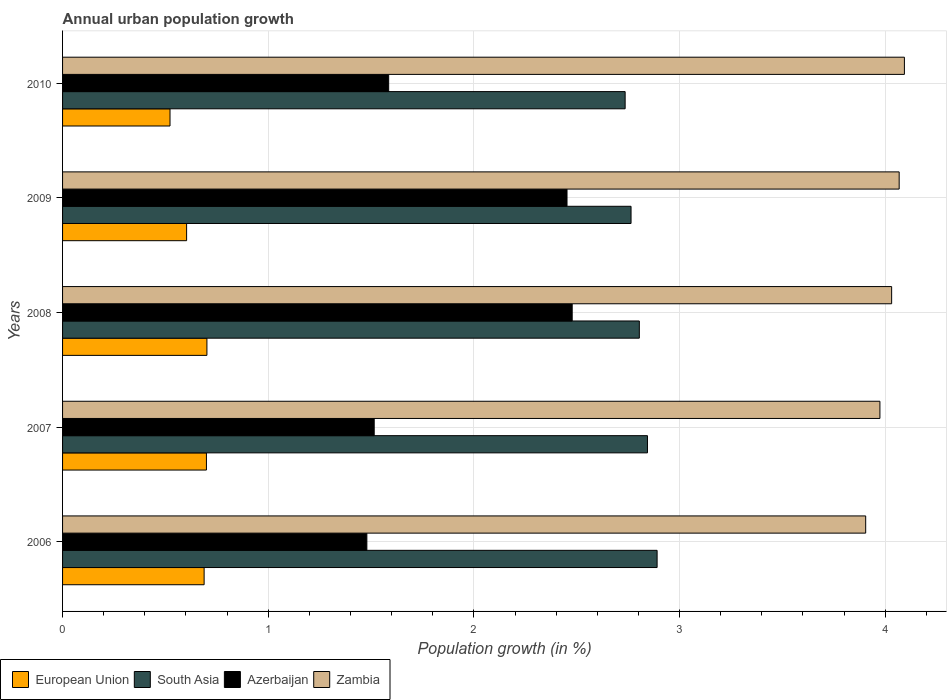How many groups of bars are there?
Provide a succinct answer. 5. Are the number of bars on each tick of the Y-axis equal?
Keep it short and to the point. Yes. In how many cases, is the number of bars for a given year not equal to the number of legend labels?
Offer a terse response. 0. What is the percentage of urban population growth in Zambia in 2006?
Offer a very short reply. 3.91. Across all years, what is the maximum percentage of urban population growth in South Asia?
Your answer should be very brief. 2.89. Across all years, what is the minimum percentage of urban population growth in Zambia?
Offer a terse response. 3.91. In which year was the percentage of urban population growth in Zambia maximum?
Make the answer very short. 2010. What is the total percentage of urban population growth in Zambia in the graph?
Your response must be concise. 20.07. What is the difference between the percentage of urban population growth in South Asia in 2007 and that in 2009?
Your answer should be compact. 0.08. What is the difference between the percentage of urban population growth in Azerbaijan in 2006 and the percentage of urban population growth in European Union in 2007?
Keep it short and to the point. 0.78. What is the average percentage of urban population growth in Zambia per year?
Your answer should be very brief. 4.01. In the year 2010, what is the difference between the percentage of urban population growth in Zambia and percentage of urban population growth in Azerbaijan?
Your response must be concise. 2.51. In how many years, is the percentage of urban population growth in South Asia greater than 0.8 %?
Your answer should be compact. 5. What is the ratio of the percentage of urban population growth in Zambia in 2008 to that in 2009?
Make the answer very short. 0.99. Is the percentage of urban population growth in Zambia in 2007 less than that in 2009?
Give a very brief answer. Yes. What is the difference between the highest and the second highest percentage of urban population growth in Azerbaijan?
Your answer should be compact. 0.03. What is the difference between the highest and the lowest percentage of urban population growth in Zambia?
Provide a succinct answer. 0.19. In how many years, is the percentage of urban population growth in Azerbaijan greater than the average percentage of urban population growth in Azerbaijan taken over all years?
Give a very brief answer. 2. Is it the case that in every year, the sum of the percentage of urban population growth in European Union and percentage of urban population growth in Zambia is greater than the sum of percentage of urban population growth in South Asia and percentage of urban population growth in Azerbaijan?
Keep it short and to the point. Yes. What does the 3rd bar from the bottom in 2009 represents?
Offer a terse response. Azerbaijan. Are all the bars in the graph horizontal?
Give a very brief answer. Yes. Are the values on the major ticks of X-axis written in scientific E-notation?
Give a very brief answer. No. Does the graph contain grids?
Provide a succinct answer. Yes. Where does the legend appear in the graph?
Ensure brevity in your answer.  Bottom left. How many legend labels are there?
Give a very brief answer. 4. What is the title of the graph?
Keep it short and to the point. Annual urban population growth. Does "Sint Maarten (Dutch part)" appear as one of the legend labels in the graph?
Give a very brief answer. No. What is the label or title of the X-axis?
Give a very brief answer. Population growth (in %). What is the label or title of the Y-axis?
Give a very brief answer. Years. What is the Population growth (in %) of European Union in 2006?
Your answer should be compact. 0.69. What is the Population growth (in %) in South Asia in 2006?
Keep it short and to the point. 2.89. What is the Population growth (in %) of Azerbaijan in 2006?
Provide a short and direct response. 1.48. What is the Population growth (in %) of Zambia in 2006?
Provide a short and direct response. 3.91. What is the Population growth (in %) of European Union in 2007?
Keep it short and to the point. 0.7. What is the Population growth (in %) in South Asia in 2007?
Offer a very short reply. 2.84. What is the Population growth (in %) in Azerbaijan in 2007?
Make the answer very short. 1.52. What is the Population growth (in %) of Zambia in 2007?
Your answer should be very brief. 3.97. What is the Population growth (in %) in European Union in 2008?
Offer a very short reply. 0.7. What is the Population growth (in %) of South Asia in 2008?
Keep it short and to the point. 2.8. What is the Population growth (in %) in Azerbaijan in 2008?
Ensure brevity in your answer.  2.48. What is the Population growth (in %) of Zambia in 2008?
Ensure brevity in your answer.  4.03. What is the Population growth (in %) of European Union in 2009?
Your answer should be compact. 0.6. What is the Population growth (in %) of South Asia in 2009?
Provide a succinct answer. 2.76. What is the Population growth (in %) of Azerbaijan in 2009?
Provide a succinct answer. 2.45. What is the Population growth (in %) of Zambia in 2009?
Offer a very short reply. 4.07. What is the Population growth (in %) of European Union in 2010?
Make the answer very short. 0.52. What is the Population growth (in %) in South Asia in 2010?
Make the answer very short. 2.74. What is the Population growth (in %) in Azerbaijan in 2010?
Your answer should be compact. 1.59. What is the Population growth (in %) in Zambia in 2010?
Make the answer very short. 4.09. Across all years, what is the maximum Population growth (in %) of European Union?
Your response must be concise. 0.7. Across all years, what is the maximum Population growth (in %) of South Asia?
Offer a terse response. 2.89. Across all years, what is the maximum Population growth (in %) in Azerbaijan?
Provide a short and direct response. 2.48. Across all years, what is the maximum Population growth (in %) of Zambia?
Keep it short and to the point. 4.09. Across all years, what is the minimum Population growth (in %) in European Union?
Your answer should be compact. 0.52. Across all years, what is the minimum Population growth (in %) in South Asia?
Ensure brevity in your answer.  2.74. Across all years, what is the minimum Population growth (in %) of Azerbaijan?
Your answer should be compact. 1.48. Across all years, what is the minimum Population growth (in %) in Zambia?
Give a very brief answer. 3.91. What is the total Population growth (in %) of European Union in the graph?
Your answer should be compact. 3.22. What is the total Population growth (in %) of South Asia in the graph?
Provide a short and direct response. 14.04. What is the total Population growth (in %) of Azerbaijan in the graph?
Provide a short and direct response. 9.51. What is the total Population growth (in %) in Zambia in the graph?
Your response must be concise. 20.07. What is the difference between the Population growth (in %) of European Union in 2006 and that in 2007?
Keep it short and to the point. -0.01. What is the difference between the Population growth (in %) in South Asia in 2006 and that in 2007?
Make the answer very short. 0.05. What is the difference between the Population growth (in %) in Azerbaijan in 2006 and that in 2007?
Keep it short and to the point. -0.04. What is the difference between the Population growth (in %) of Zambia in 2006 and that in 2007?
Make the answer very short. -0.07. What is the difference between the Population growth (in %) of European Union in 2006 and that in 2008?
Your response must be concise. -0.01. What is the difference between the Population growth (in %) of South Asia in 2006 and that in 2008?
Provide a succinct answer. 0.09. What is the difference between the Population growth (in %) in Azerbaijan in 2006 and that in 2008?
Ensure brevity in your answer.  -1. What is the difference between the Population growth (in %) in Zambia in 2006 and that in 2008?
Give a very brief answer. -0.13. What is the difference between the Population growth (in %) in European Union in 2006 and that in 2009?
Offer a terse response. 0.09. What is the difference between the Population growth (in %) in South Asia in 2006 and that in 2009?
Give a very brief answer. 0.13. What is the difference between the Population growth (in %) of Azerbaijan in 2006 and that in 2009?
Provide a succinct answer. -0.97. What is the difference between the Population growth (in %) of Zambia in 2006 and that in 2009?
Provide a short and direct response. -0.16. What is the difference between the Population growth (in %) of European Union in 2006 and that in 2010?
Offer a terse response. 0.17. What is the difference between the Population growth (in %) in South Asia in 2006 and that in 2010?
Give a very brief answer. 0.16. What is the difference between the Population growth (in %) of Azerbaijan in 2006 and that in 2010?
Your response must be concise. -0.11. What is the difference between the Population growth (in %) of Zambia in 2006 and that in 2010?
Keep it short and to the point. -0.19. What is the difference between the Population growth (in %) in European Union in 2007 and that in 2008?
Offer a terse response. -0. What is the difference between the Population growth (in %) in South Asia in 2007 and that in 2008?
Make the answer very short. 0.04. What is the difference between the Population growth (in %) in Azerbaijan in 2007 and that in 2008?
Make the answer very short. -0.96. What is the difference between the Population growth (in %) in Zambia in 2007 and that in 2008?
Ensure brevity in your answer.  -0.06. What is the difference between the Population growth (in %) of European Union in 2007 and that in 2009?
Provide a succinct answer. 0.1. What is the difference between the Population growth (in %) in South Asia in 2007 and that in 2009?
Your response must be concise. 0.08. What is the difference between the Population growth (in %) in Azerbaijan in 2007 and that in 2009?
Your response must be concise. -0.94. What is the difference between the Population growth (in %) in Zambia in 2007 and that in 2009?
Offer a terse response. -0.09. What is the difference between the Population growth (in %) of European Union in 2007 and that in 2010?
Keep it short and to the point. 0.18. What is the difference between the Population growth (in %) in South Asia in 2007 and that in 2010?
Keep it short and to the point. 0.11. What is the difference between the Population growth (in %) in Azerbaijan in 2007 and that in 2010?
Your answer should be very brief. -0.07. What is the difference between the Population growth (in %) of Zambia in 2007 and that in 2010?
Make the answer very short. -0.12. What is the difference between the Population growth (in %) in European Union in 2008 and that in 2009?
Provide a succinct answer. 0.1. What is the difference between the Population growth (in %) in South Asia in 2008 and that in 2009?
Make the answer very short. 0.04. What is the difference between the Population growth (in %) in Azerbaijan in 2008 and that in 2009?
Ensure brevity in your answer.  0.03. What is the difference between the Population growth (in %) in Zambia in 2008 and that in 2009?
Offer a very short reply. -0.04. What is the difference between the Population growth (in %) of European Union in 2008 and that in 2010?
Your response must be concise. 0.18. What is the difference between the Population growth (in %) in South Asia in 2008 and that in 2010?
Your answer should be compact. 0.07. What is the difference between the Population growth (in %) of Azerbaijan in 2008 and that in 2010?
Provide a succinct answer. 0.89. What is the difference between the Population growth (in %) in Zambia in 2008 and that in 2010?
Keep it short and to the point. -0.06. What is the difference between the Population growth (in %) of European Union in 2009 and that in 2010?
Give a very brief answer. 0.08. What is the difference between the Population growth (in %) of South Asia in 2009 and that in 2010?
Give a very brief answer. 0.03. What is the difference between the Population growth (in %) of Azerbaijan in 2009 and that in 2010?
Offer a terse response. 0.87. What is the difference between the Population growth (in %) of Zambia in 2009 and that in 2010?
Make the answer very short. -0.03. What is the difference between the Population growth (in %) of European Union in 2006 and the Population growth (in %) of South Asia in 2007?
Keep it short and to the point. -2.16. What is the difference between the Population growth (in %) of European Union in 2006 and the Population growth (in %) of Azerbaijan in 2007?
Keep it short and to the point. -0.83. What is the difference between the Population growth (in %) in European Union in 2006 and the Population growth (in %) in Zambia in 2007?
Give a very brief answer. -3.29. What is the difference between the Population growth (in %) of South Asia in 2006 and the Population growth (in %) of Azerbaijan in 2007?
Provide a short and direct response. 1.38. What is the difference between the Population growth (in %) in South Asia in 2006 and the Population growth (in %) in Zambia in 2007?
Provide a short and direct response. -1.08. What is the difference between the Population growth (in %) of Azerbaijan in 2006 and the Population growth (in %) of Zambia in 2007?
Your answer should be very brief. -2.49. What is the difference between the Population growth (in %) in European Union in 2006 and the Population growth (in %) in South Asia in 2008?
Offer a very short reply. -2.12. What is the difference between the Population growth (in %) in European Union in 2006 and the Population growth (in %) in Azerbaijan in 2008?
Offer a terse response. -1.79. What is the difference between the Population growth (in %) in European Union in 2006 and the Population growth (in %) in Zambia in 2008?
Make the answer very short. -3.34. What is the difference between the Population growth (in %) in South Asia in 2006 and the Population growth (in %) in Azerbaijan in 2008?
Provide a short and direct response. 0.41. What is the difference between the Population growth (in %) in South Asia in 2006 and the Population growth (in %) in Zambia in 2008?
Your response must be concise. -1.14. What is the difference between the Population growth (in %) of Azerbaijan in 2006 and the Population growth (in %) of Zambia in 2008?
Give a very brief answer. -2.55. What is the difference between the Population growth (in %) in European Union in 2006 and the Population growth (in %) in South Asia in 2009?
Your answer should be very brief. -2.08. What is the difference between the Population growth (in %) of European Union in 2006 and the Population growth (in %) of Azerbaijan in 2009?
Offer a terse response. -1.76. What is the difference between the Population growth (in %) of European Union in 2006 and the Population growth (in %) of Zambia in 2009?
Offer a very short reply. -3.38. What is the difference between the Population growth (in %) of South Asia in 2006 and the Population growth (in %) of Azerbaijan in 2009?
Keep it short and to the point. 0.44. What is the difference between the Population growth (in %) in South Asia in 2006 and the Population growth (in %) in Zambia in 2009?
Provide a short and direct response. -1.18. What is the difference between the Population growth (in %) in Azerbaijan in 2006 and the Population growth (in %) in Zambia in 2009?
Offer a terse response. -2.59. What is the difference between the Population growth (in %) in European Union in 2006 and the Population growth (in %) in South Asia in 2010?
Keep it short and to the point. -2.05. What is the difference between the Population growth (in %) of European Union in 2006 and the Population growth (in %) of Azerbaijan in 2010?
Offer a terse response. -0.9. What is the difference between the Population growth (in %) in European Union in 2006 and the Population growth (in %) in Zambia in 2010?
Offer a very short reply. -3.4. What is the difference between the Population growth (in %) of South Asia in 2006 and the Population growth (in %) of Azerbaijan in 2010?
Your answer should be compact. 1.31. What is the difference between the Population growth (in %) of South Asia in 2006 and the Population growth (in %) of Zambia in 2010?
Give a very brief answer. -1.2. What is the difference between the Population growth (in %) in Azerbaijan in 2006 and the Population growth (in %) in Zambia in 2010?
Ensure brevity in your answer.  -2.61. What is the difference between the Population growth (in %) of European Union in 2007 and the Population growth (in %) of South Asia in 2008?
Give a very brief answer. -2.1. What is the difference between the Population growth (in %) of European Union in 2007 and the Population growth (in %) of Azerbaijan in 2008?
Make the answer very short. -1.78. What is the difference between the Population growth (in %) in European Union in 2007 and the Population growth (in %) in Zambia in 2008?
Ensure brevity in your answer.  -3.33. What is the difference between the Population growth (in %) of South Asia in 2007 and the Population growth (in %) of Azerbaijan in 2008?
Offer a terse response. 0.37. What is the difference between the Population growth (in %) of South Asia in 2007 and the Population growth (in %) of Zambia in 2008?
Your answer should be very brief. -1.19. What is the difference between the Population growth (in %) in Azerbaijan in 2007 and the Population growth (in %) in Zambia in 2008?
Offer a terse response. -2.52. What is the difference between the Population growth (in %) of European Union in 2007 and the Population growth (in %) of South Asia in 2009?
Offer a terse response. -2.06. What is the difference between the Population growth (in %) in European Union in 2007 and the Population growth (in %) in Azerbaijan in 2009?
Your answer should be very brief. -1.75. What is the difference between the Population growth (in %) in European Union in 2007 and the Population growth (in %) in Zambia in 2009?
Ensure brevity in your answer.  -3.37. What is the difference between the Population growth (in %) in South Asia in 2007 and the Population growth (in %) in Azerbaijan in 2009?
Provide a succinct answer. 0.39. What is the difference between the Population growth (in %) of South Asia in 2007 and the Population growth (in %) of Zambia in 2009?
Your response must be concise. -1.22. What is the difference between the Population growth (in %) in Azerbaijan in 2007 and the Population growth (in %) in Zambia in 2009?
Provide a succinct answer. -2.55. What is the difference between the Population growth (in %) in European Union in 2007 and the Population growth (in %) in South Asia in 2010?
Make the answer very short. -2.04. What is the difference between the Population growth (in %) in European Union in 2007 and the Population growth (in %) in Azerbaijan in 2010?
Offer a very short reply. -0.89. What is the difference between the Population growth (in %) of European Union in 2007 and the Population growth (in %) of Zambia in 2010?
Provide a succinct answer. -3.39. What is the difference between the Population growth (in %) of South Asia in 2007 and the Population growth (in %) of Azerbaijan in 2010?
Keep it short and to the point. 1.26. What is the difference between the Population growth (in %) in South Asia in 2007 and the Population growth (in %) in Zambia in 2010?
Offer a terse response. -1.25. What is the difference between the Population growth (in %) of Azerbaijan in 2007 and the Population growth (in %) of Zambia in 2010?
Your answer should be very brief. -2.58. What is the difference between the Population growth (in %) of European Union in 2008 and the Population growth (in %) of South Asia in 2009?
Your answer should be compact. -2.06. What is the difference between the Population growth (in %) of European Union in 2008 and the Population growth (in %) of Azerbaijan in 2009?
Provide a succinct answer. -1.75. What is the difference between the Population growth (in %) of European Union in 2008 and the Population growth (in %) of Zambia in 2009?
Keep it short and to the point. -3.37. What is the difference between the Population growth (in %) in South Asia in 2008 and the Population growth (in %) in Azerbaijan in 2009?
Offer a very short reply. 0.35. What is the difference between the Population growth (in %) in South Asia in 2008 and the Population growth (in %) in Zambia in 2009?
Give a very brief answer. -1.26. What is the difference between the Population growth (in %) in Azerbaijan in 2008 and the Population growth (in %) in Zambia in 2009?
Provide a succinct answer. -1.59. What is the difference between the Population growth (in %) in European Union in 2008 and the Population growth (in %) in South Asia in 2010?
Ensure brevity in your answer.  -2.03. What is the difference between the Population growth (in %) in European Union in 2008 and the Population growth (in %) in Azerbaijan in 2010?
Make the answer very short. -0.88. What is the difference between the Population growth (in %) of European Union in 2008 and the Population growth (in %) of Zambia in 2010?
Offer a terse response. -3.39. What is the difference between the Population growth (in %) in South Asia in 2008 and the Population growth (in %) in Azerbaijan in 2010?
Provide a succinct answer. 1.22. What is the difference between the Population growth (in %) in South Asia in 2008 and the Population growth (in %) in Zambia in 2010?
Your answer should be compact. -1.29. What is the difference between the Population growth (in %) of Azerbaijan in 2008 and the Population growth (in %) of Zambia in 2010?
Offer a terse response. -1.62. What is the difference between the Population growth (in %) of European Union in 2009 and the Population growth (in %) of South Asia in 2010?
Keep it short and to the point. -2.13. What is the difference between the Population growth (in %) of European Union in 2009 and the Population growth (in %) of Azerbaijan in 2010?
Your answer should be very brief. -0.98. What is the difference between the Population growth (in %) in European Union in 2009 and the Population growth (in %) in Zambia in 2010?
Provide a short and direct response. -3.49. What is the difference between the Population growth (in %) in South Asia in 2009 and the Population growth (in %) in Azerbaijan in 2010?
Offer a very short reply. 1.18. What is the difference between the Population growth (in %) of South Asia in 2009 and the Population growth (in %) of Zambia in 2010?
Offer a terse response. -1.33. What is the difference between the Population growth (in %) in Azerbaijan in 2009 and the Population growth (in %) in Zambia in 2010?
Provide a short and direct response. -1.64. What is the average Population growth (in %) in European Union per year?
Keep it short and to the point. 0.64. What is the average Population growth (in %) of South Asia per year?
Keep it short and to the point. 2.81. What is the average Population growth (in %) in Azerbaijan per year?
Keep it short and to the point. 1.9. What is the average Population growth (in %) of Zambia per year?
Give a very brief answer. 4.01. In the year 2006, what is the difference between the Population growth (in %) of European Union and Population growth (in %) of South Asia?
Offer a very short reply. -2.2. In the year 2006, what is the difference between the Population growth (in %) in European Union and Population growth (in %) in Azerbaijan?
Your answer should be compact. -0.79. In the year 2006, what is the difference between the Population growth (in %) in European Union and Population growth (in %) in Zambia?
Your response must be concise. -3.22. In the year 2006, what is the difference between the Population growth (in %) of South Asia and Population growth (in %) of Azerbaijan?
Offer a terse response. 1.41. In the year 2006, what is the difference between the Population growth (in %) of South Asia and Population growth (in %) of Zambia?
Provide a succinct answer. -1.01. In the year 2006, what is the difference between the Population growth (in %) of Azerbaijan and Population growth (in %) of Zambia?
Ensure brevity in your answer.  -2.43. In the year 2007, what is the difference between the Population growth (in %) in European Union and Population growth (in %) in South Asia?
Ensure brevity in your answer.  -2.14. In the year 2007, what is the difference between the Population growth (in %) of European Union and Population growth (in %) of Azerbaijan?
Provide a succinct answer. -0.82. In the year 2007, what is the difference between the Population growth (in %) of European Union and Population growth (in %) of Zambia?
Your answer should be very brief. -3.27. In the year 2007, what is the difference between the Population growth (in %) of South Asia and Population growth (in %) of Azerbaijan?
Your answer should be very brief. 1.33. In the year 2007, what is the difference between the Population growth (in %) of South Asia and Population growth (in %) of Zambia?
Offer a very short reply. -1.13. In the year 2007, what is the difference between the Population growth (in %) in Azerbaijan and Population growth (in %) in Zambia?
Your response must be concise. -2.46. In the year 2008, what is the difference between the Population growth (in %) in European Union and Population growth (in %) in South Asia?
Offer a very short reply. -2.1. In the year 2008, what is the difference between the Population growth (in %) of European Union and Population growth (in %) of Azerbaijan?
Make the answer very short. -1.78. In the year 2008, what is the difference between the Population growth (in %) of European Union and Population growth (in %) of Zambia?
Your response must be concise. -3.33. In the year 2008, what is the difference between the Population growth (in %) of South Asia and Population growth (in %) of Azerbaijan?
Offer a terse response. 0.33. In the year 2008, what is the difference between the Population growth (in %) in South Asia and Population growth (in %) in Zambia?
Give a very brief answer. -1.23. In the year 2008, what is the difference between the Population growth (in %) in Azerbaijan and Population growth (in %) in Zambia?
Offer a terse response. -1.55. In the year 2009, what is the difference between the Population growth (in %) of European Union and Population growth (in %) of South Asia?
Ensure brevity in your answer.  -2.16. In the year 2009, what is the difference between the Population growth (in %) of European Union and Population growth (in %) of Azerbaijan?
Offer a terse response. -1.85. In the year 2009, what is the difference between the Population growth (in %) of European Union and Population growth (in %) of Zambia?
Give a very brief answer. -3.46. In the year 2009, what is the difference between the Population growth (in %) in South Asia and Population growth (in %) in Azerbaijan?
Keep it short and to the point. 0.31. In the year 2009, what is the difference between the Population growth (in %) of South Asia and Population growth (in %) of Zambia?
Make the answer very short. -1.3. In the year 2009, what is the difference between the Population growth (in %) of Azerbaijan and Population growth (in %) of Zambia?
Your answer should be compact. -1.61. In the year 2010, what is the difference between the Population growth (in %) of European Union and Population growth (in %) of South Asia?
Ensure brevity in your answer.  -2.21. In the year 2010, what is the difference between the Population growth (in %) of European Union and Population growth (in %) of Azerbaijan?
Keep it short and to the point. -1.06. In the year 2010, what is the difference between the Population growth (in %) in European Union and Population growth (in %) in Zambia?
Your answer should be very brief. -3.57. In the year 2010, what is the difference between the Population growth (in %) of South Asia and Population growth (in %) of Azerbaijan?
Give a very brief answer. 1.15. In the year 2010, what is the difference between the Population growth (in %) in South Asia and Population growth (in %) in Zambia?
Keep it short and to the point. -1.36. In the year 2010, what is the difference between the Population growth (in %) in Azerbaijan and Population growth (in %) in Zambia?
Provide a succinct answer. -2.51. What is the ratio of the Population growth (in %) of European Union in 2006 to that in 2007?
Your answer should be compact. 0.98. What is the ratio of the Population growth (in %) in South Asia in 2006 to that in 2007?
Your answer should be compact. 1.02. What is the ratio of the Population growth (in %) of Azerbaijan in 2006 to that in 2007?
Your response must be concise. 0.98. What is the ratio of the Population growth (in %) of Zambia in 2006 to that in 2007?
Provide a succinct answer. 0.98. What is the ratio of the Population growth (in %) of European Union in 2006 to that in 2008?
Ensure brevity in your answer.  0.98. What is the ratio of the Population growth (in %) in South Asia in 2006 to that in 2008?
Keep it short and to the point. 1.03. What is the ratio of the Population growth (in %) of Azerbaijan in 2006 to that in 2008?
Ensure brevity in your answer.  0.6. What is the ratio of the Population growth (in %) of Zambia in 2006 to that in 2008?
Your answer should be very brief. 0.97. What is the ratio of the Population growth (in %) of European Union in 2006 to that in 2009?
Make the answer very short. 1.14. What is the ratio of the Population growth (in %) in South Asia in 2006 to that in 2009?
Provide a succinct answer. 1.05. What is the ratio of the Population growth (in %) of Azerbaijan in 2006 to that in 2009?
Your answer should be compact. 0.6. What is the ratio of the Population growth (in %) of European Union in 2006 to that in 2010?
Ensure brevity in your answer.  1.32. What is the ratio of the Population growth (in %) in South Asia in 2006 to that in 2010?
Your answer should be very brief. 1.06. What is the ratio of the Population growth (in %) in Azerbaijan in 2006 to that in 2010?
Your answer should be very brief. 0.93. What is the ratio of the Population growth (in %) of Zambia in 2006 to that in 2010?
Give a very brief answer. 0.95. What is the ratio of the Population growth (in %) in South Asia in 2007 to that in 2008?
Your answer should be very brief. 1.01. What is the ratio of the Population growth (in %) of Azerbaijan in 2007 to that in 2008?
Give a very brief answer. 0.61. What is the ratio of the Population growth (in %) in Zambia in 2007 to that in 2008?
Provide a succinct answer. 0.99. What is the ratio of the Population growth (in %) in European Union in 2007 to that in 2009?
Provide a succinct answer. 1.16. What is the ratio of the Population growth (in %) in South Asia in 2007 to that in 2009?
Offer a very short reply. 1.03. What is the ratio of the Population growth (in %) in Azerbaijan in 2007 to that in 2009?
Your response must be concise. 0.62. What is the ratio of the Population growth (in %) in European Union in 2007 to that in 2010?
Provide a short and direct response. 1.34. What is the ratio of the Population growth (in %) of South Asia in 2007 to that in 2010?
Offer a terse response. 1.04. What is the ratio of the Population growth (in %) of Azerbaijan in 2007 to that in 2010?
Keep it short and to the point. 0.96. What is the ratio of the Population growth (in %) of Zambia in 2007 to that in 2010?
Offer a very short reply. 0.97. What is the ratio of the Population growth (in %) in European Union in 2008 to that in 2009?
Your answer should be very brief. 1.16. What is the ratio of the Population growth (in %) in South Asia in 2008 to that in 2009?
Give a very brief answer. 1.01. What is the ratio of the Population growth (in %) in Azerbaijan in 2008 to that in 2009?
Make the answer very short. 1.01. What is the ratio of the Population growth (in %) in Zambia in 2008 to that in 2009?
Make the answer very short. 0.99. What is the ratio of the Population growth (in %) of European Union in 2008 to that in 2010?
Ensure brevity in your answer.  1.34. What is the ratio of the Population growth (in %) in South Asia in 2008 to that in 2010?
Make the answer very short. 1.03. What is the ratio of the Population growth (in %) of Azerbaijan in 2008 to that in 2010?
Provide a short and direct response. 1.56. What is the ratio of the Population growth (in %) in European Union in 2009 to that in 2010?
Offer a terse response. 1.15. What is the ratio of the Population growth (in %) of South Asia in 2009 to that in 2010?
Your response must be concise. 1.01. What is the ratio of the Population growth (in %) in Azerbaijan in 2009 to that in 2010?
Make the answer very short. 1.55. What is the difference between the highest and the second highest Population growth (in %) in European Union?
Your response must be concise. 0. What is the difference between the highest and the second highest Population growth (in %) in South Asia?
Your answer should be very brief. 0.05. What is the difference between the highest and the second highest Population growth (in %) in Azerbaijan?
Your response must be concise. 0.03. What is the difference between the highest and the second highest Population growth (in %) in Zambia?
Keep it short and to the point. 0.03. What is the difference between the highest and the lowest Population growth (in %) of European Union?
Keep it short and to the point. 0.18. What is the difference between the highest and the lowest Population growth (in %) of South Asia?
Ensure brevity in your answer.  0.16. What is the difference between the highest and the lowest Population growth (in %) in Zambia?
Keep it short and to the point. 0.19. 